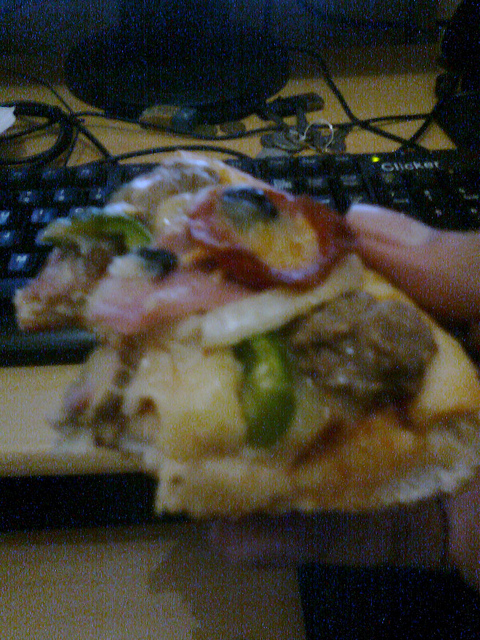Is this at a restaurant? No, it does not appear to be in a restaurant, given the presence of a computer keyboard, suggesting an office or home setting. 